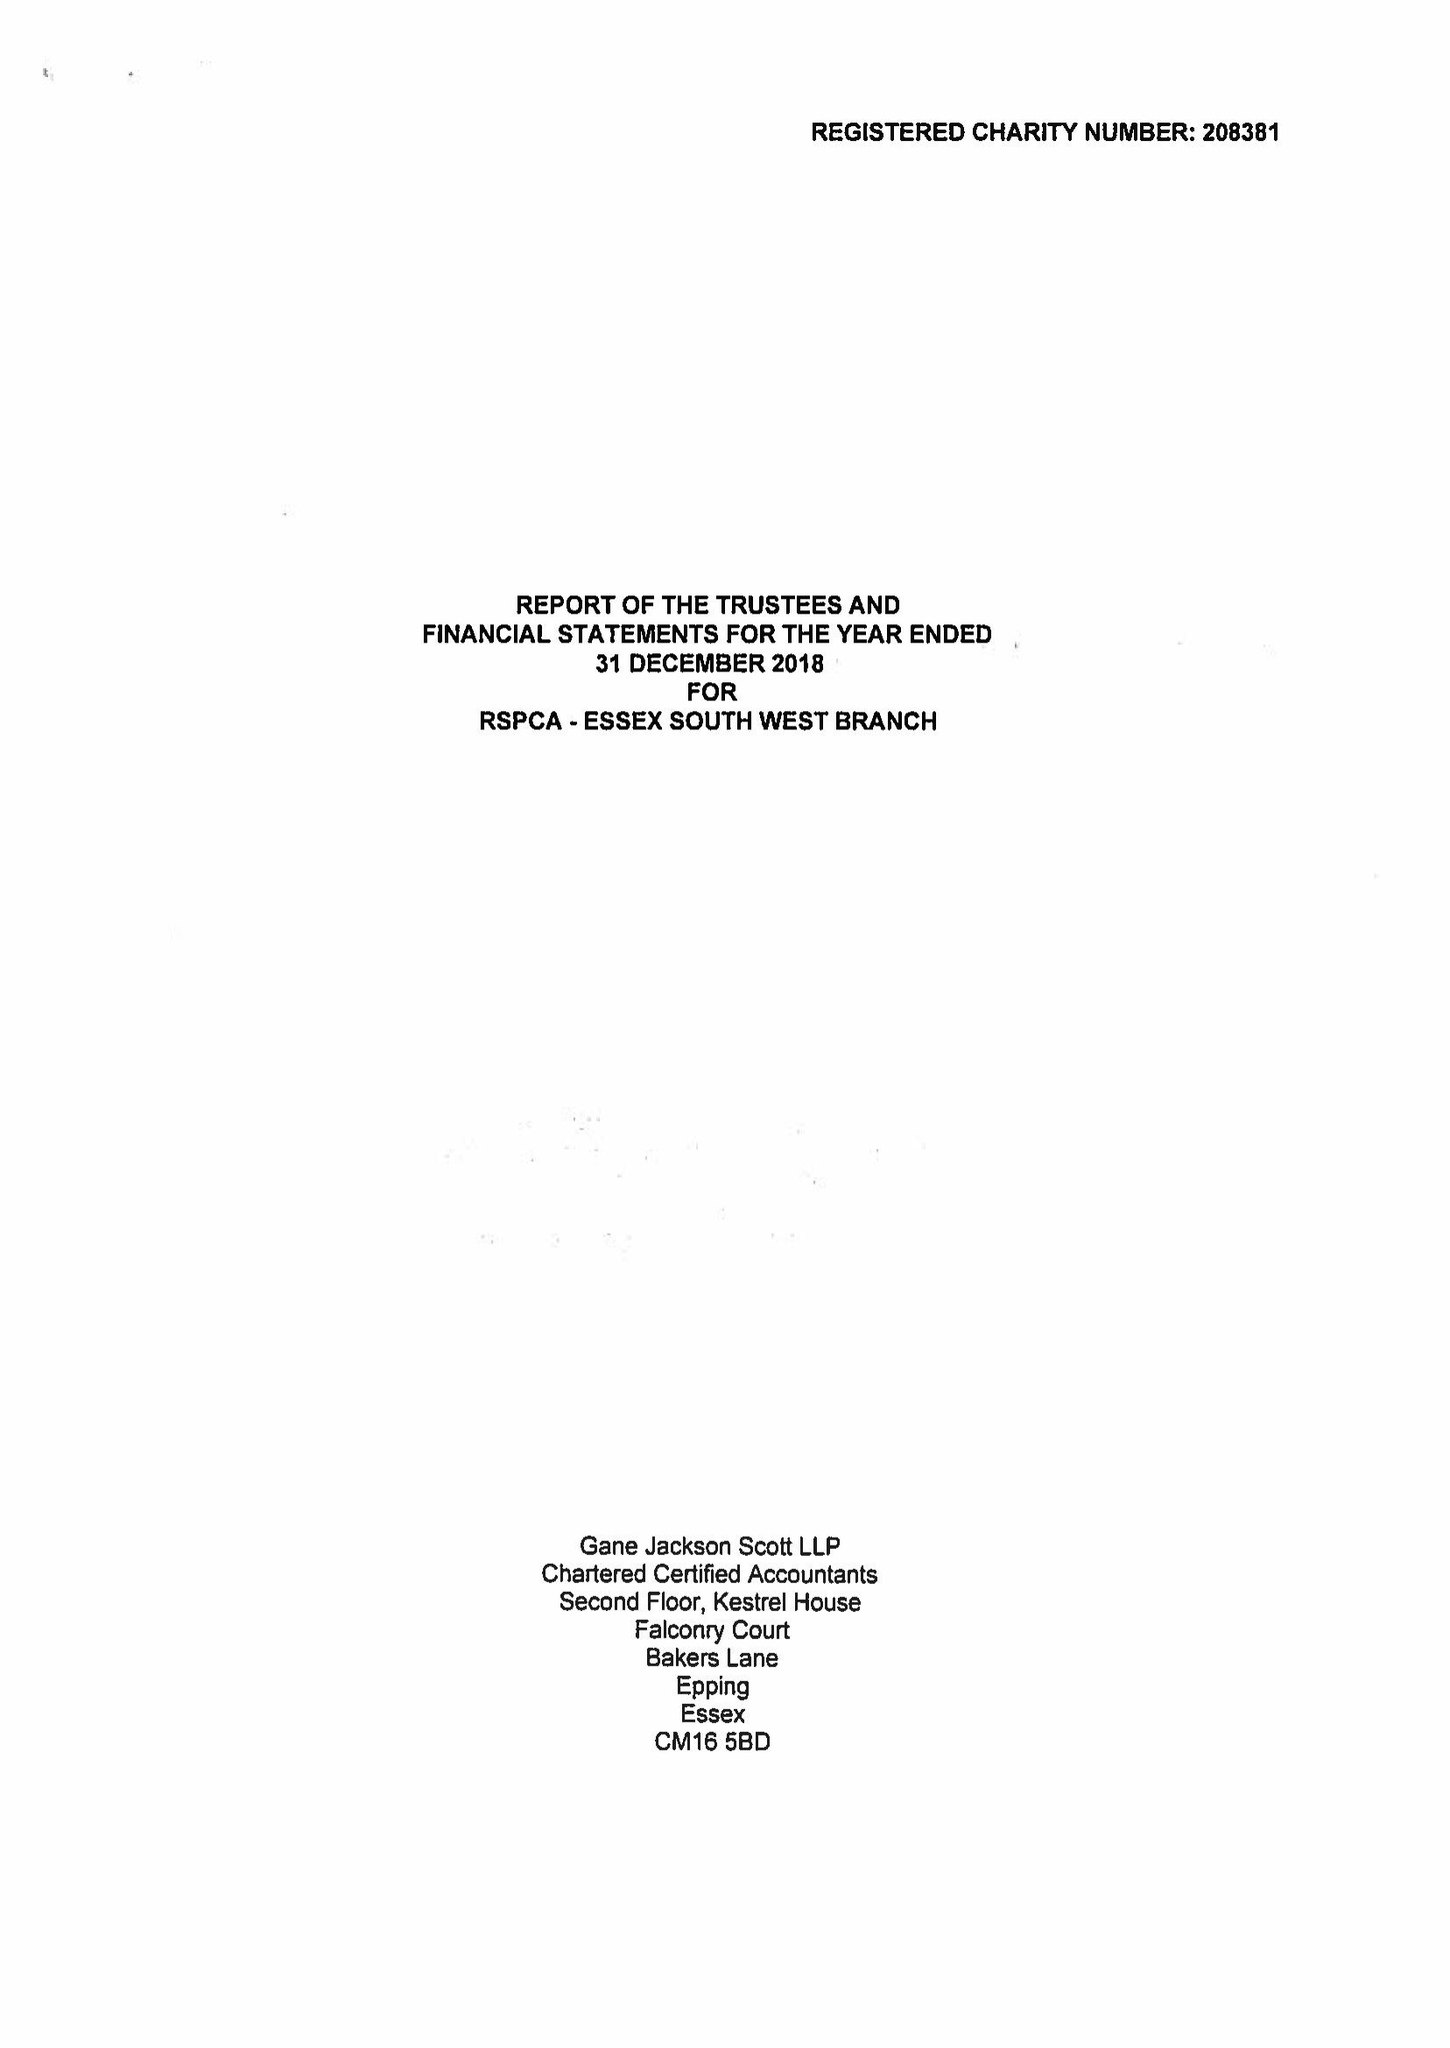What is the value for the spending_annually_in_british_pounds?
Answer the question using a single word or phrase. 32815.00 